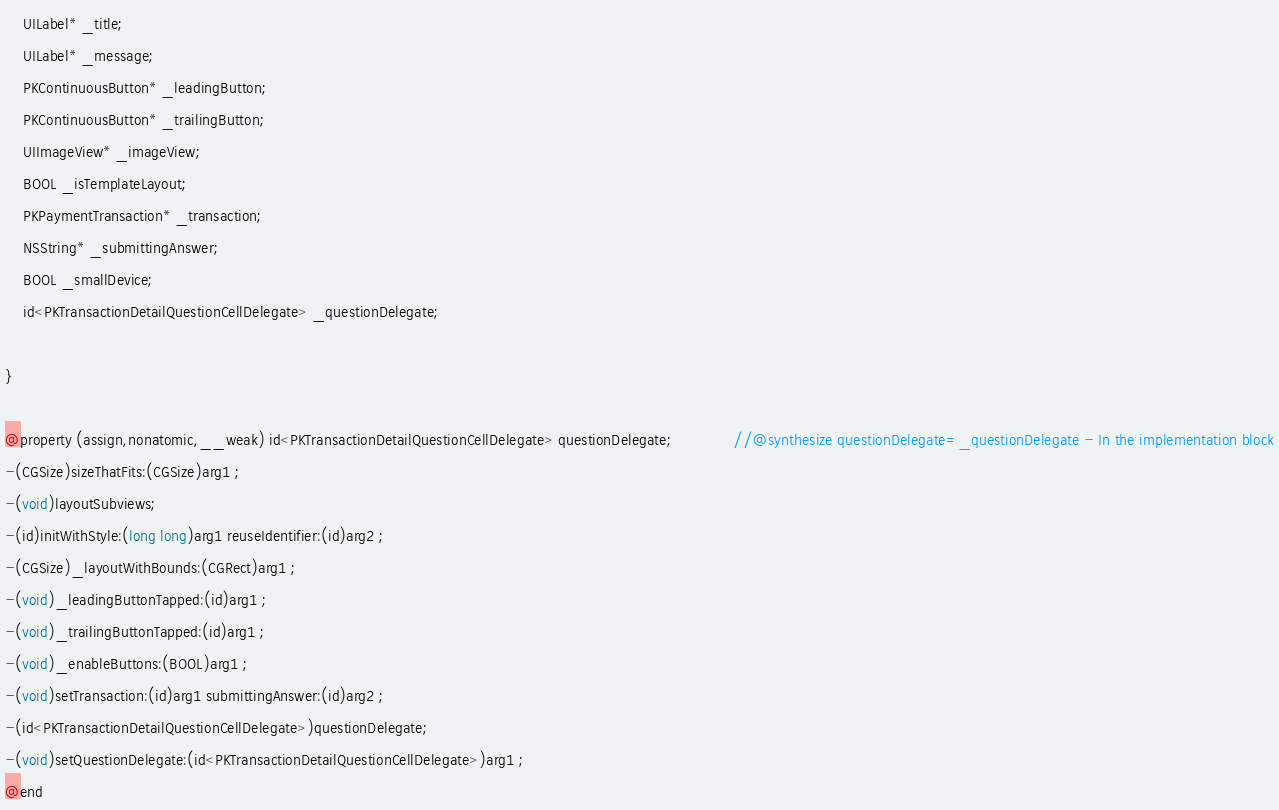<code> <loc_0><loc_0><loc_500><loc_500><_C_>
	UILabel* _title;
	UILabel* _message;
	PKContinuousButton* _leadingButton;
	PKContinuousButton* _trailingButton;
	UIImageView* _imageView;
	BOOL _isTemplateLayout;
	PKPaymentTransaction* _transaction;
	NSString* _submittingAnswer;
	BOOL _smallDevice;
	id<PKTransactionDetailQuestionCellDelegate> _questionDelegate;

}

@property (assign,nonatomic,__weak) id<PKTransactionDetailQuestionCellDelegate> questionDelegate;              //@synthesize questionDelegate=_questionDelegate - In the implementation block
-(CGSize)sizeThatFits:(CGSize)arg1 ;
-(void)layoutSubviews;
-(id)initWithStyle:(long long)arg1 reuseIdentifier:(id)arg2 ;
-(CGSize)_layoutWithBounds:(CGRect)arg1 ;
-(void)_leadingButtonTapped:(id)arg1 ;
-(void)_trailingButtonTapped:(id)arg1 ;
-(void)_enableButtons:(BOOL)arg1 ;
-(void)setTransaction:(id)arg1 submittingAnswer:(id)arg2 ;
-(id<PKTransactionDetailQuestionCellDelegate>)questionDelegate;
-(void)setQuestionDelegate:(id<PKTransactionDetailQuestionCellDelegate>)arg1 ;
@end

</code> 